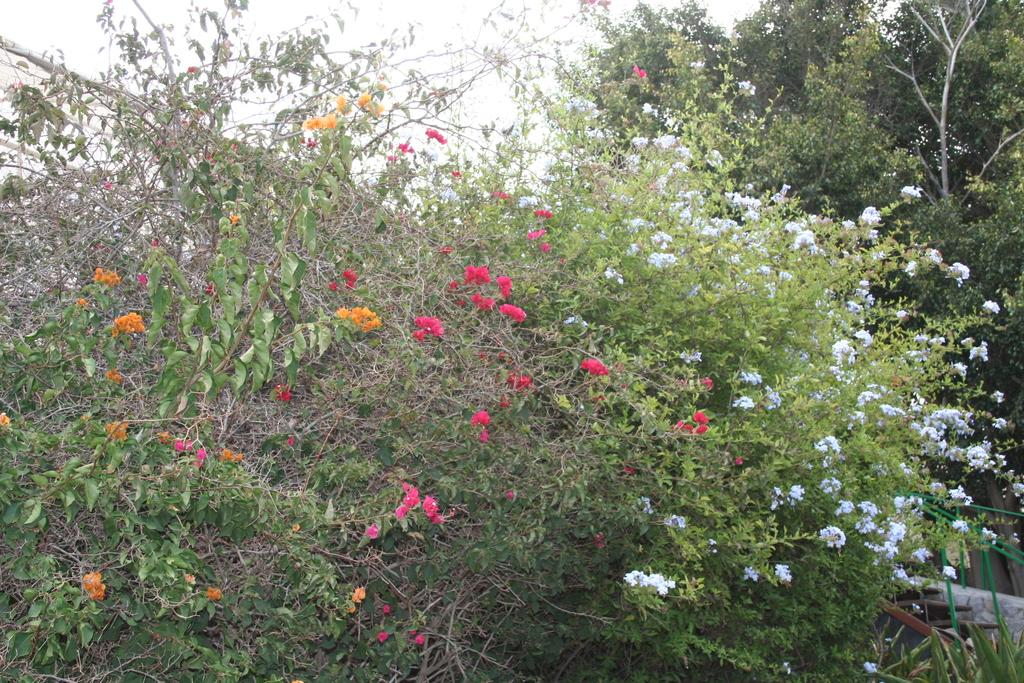What types of plants can be seen in the image? There are many plants with flowers in the image. What can be seen in the background of the image? There are trees and the sky visible in the background of the image. What type of lipstick is the tree wearing in the image? There is no lipstick or indication of makeup in the image; it features plants, trees, and the sky. 